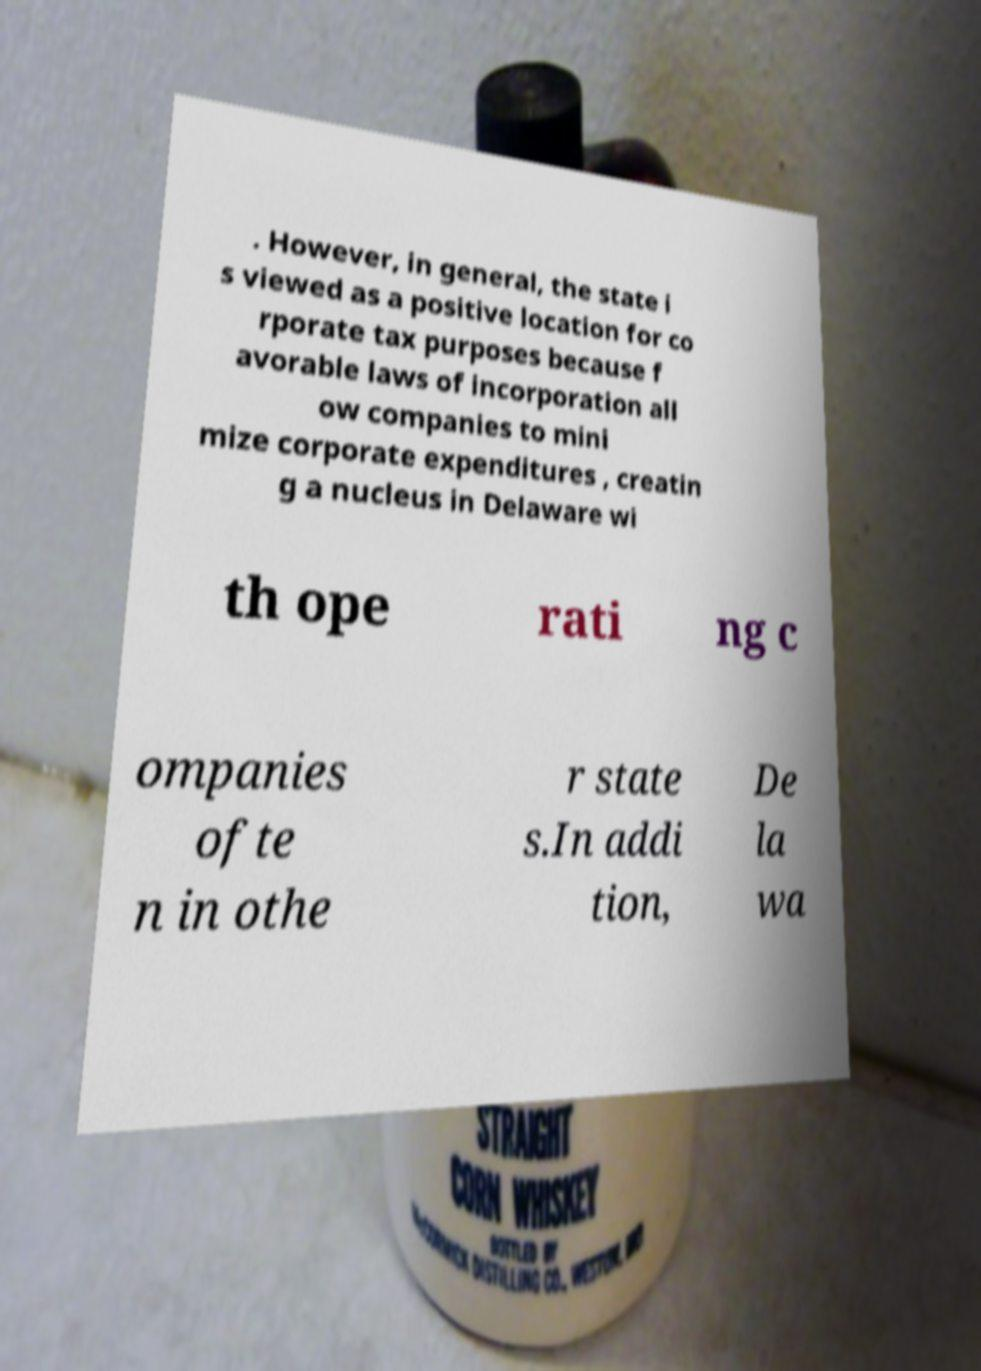Please read and relay the text visible in this image. What does it say? . However, in general, the state i s viewed as a positive location for co rporate tax purposes because f avorable laws of incorporation all ow companies to mini mize corporate expenditures , creatin g a nucleus in Delaware wi th ope rati ng c ompanies ofte n in othe r state s.In addi tion, De la wa 